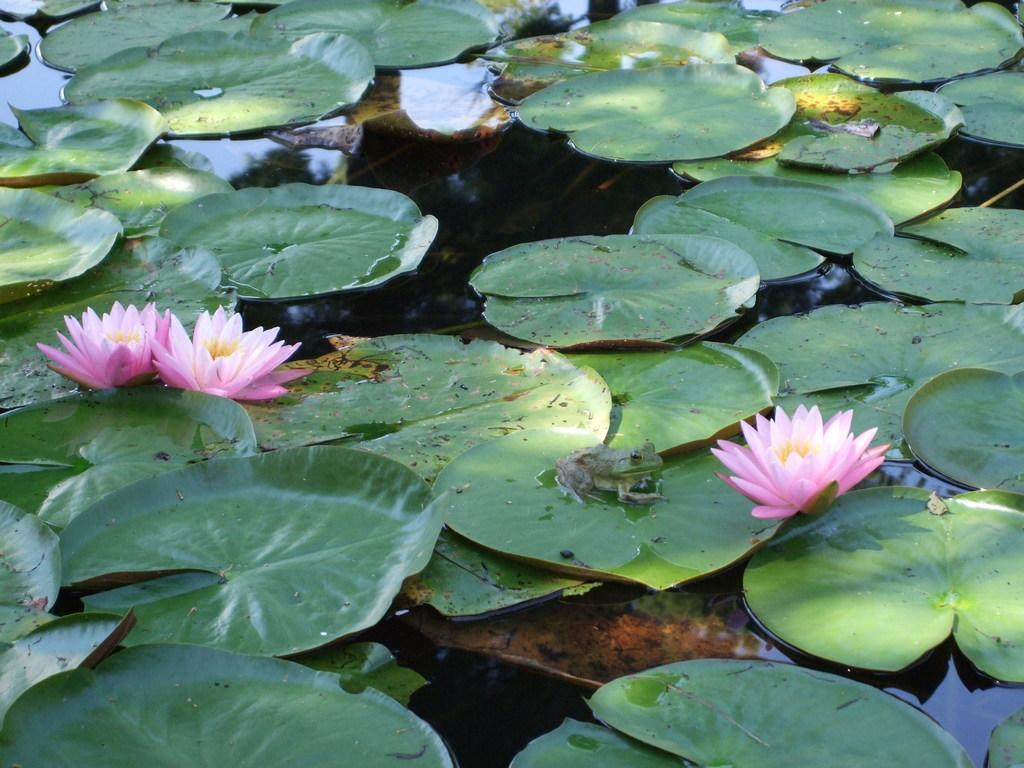What is floating on the surface of the water in the image? There are leaves and lotus flowers on the surface of the water. Can you describe the appearance of the lotus flowers? The lotus flowers are visible on the surface of the water. What type of milk can be seen in the image? There is no milk present in the image. Is there a woman shopping at a market in the image? There is no woman or market present in the image. 